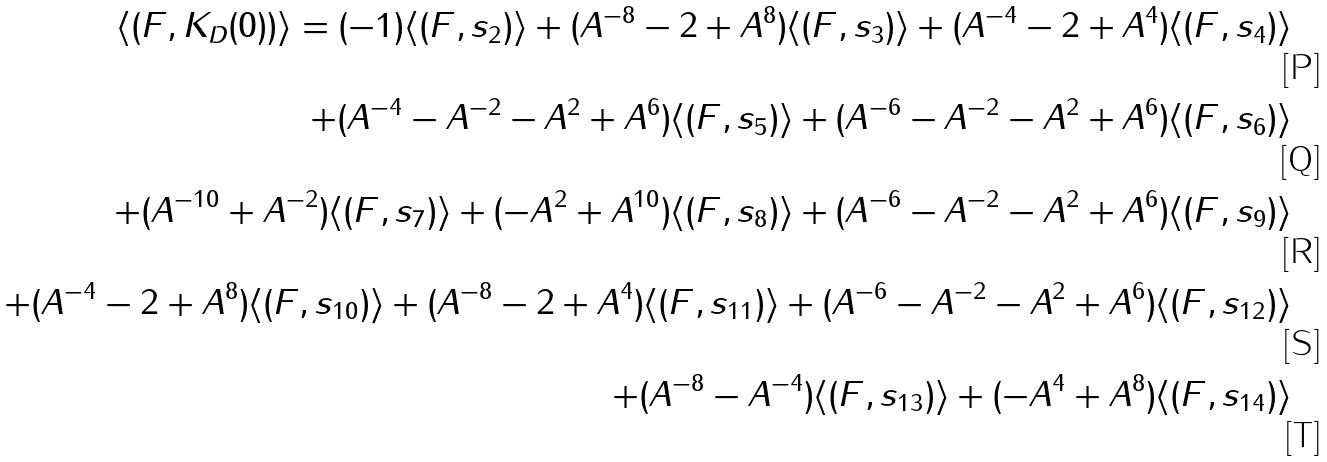<formula> <loc_0><loc_0><loc_500><loc_500>\langle ( F , K _ { D } ( 0 ) ) \rangle = ( - 1 ) \langle ( F , s _ { 2 } ) \rangle + ( A ^ { - 8 } - 2 + A ^ { 8 } ) \langle ( F , s _ { 3 } ) \rangle + ( A ^ { - 4 } - 2 + A ^ { 4 } ) \langle ( F , s _ { 4 } ) \rangle \\ + ( A ^ { - 4 } - A ^ { - 2 } - A ^ { 2 } + A ^ { 6 } ) \langle ( F , s _ { 5 } ) \rangle + ( A ^ { - 6 } - A ^ { - 2 } - A ^ { 2 } + A ^ { 6 } ) \langle ( F , s _ { 6 } ) \rangle \\ + ( A ^ { - 1 0 } + A ^ { - 2 } ) \langle ( F , s _ { 7 } ) \rangle + ( - A ^ { 2 } + A ^ { 1 0 } ) \langle ( F , s _ { 8 } ) \rangle + ( A ^ { - 6 } - A ^ { - 2 } - A ^ { 2 } + A ^ { 6 } ) \langle ( F , s _ { 9 } ) \rangle \\ + ( A ^ { - 4 } - 2 + A ^ { 8 } ) \langle ( F , s _ { 1 0 } ) \rangle + ( A ^ { - 8 } - 2 + A ^ { 4 } ) \langle ( F , s _ { 1 1 } ) \rangle + ( A ^ { - 6 } - A ^ { - 2 } - A ^ { 2 } + A ^ { 6 } ) \langle ( F , s _ { 1 2 } ) \rangle \\ + ( A ^ { - 8 } - A ^ { - 4 } ) \langle ( F , s _ { 1 3 } ) \rangle + ( - A ^ { 4 } + A ^ { 8 } ) \langle ( F , s _ { 1 4 } ) \rangle</formula> 